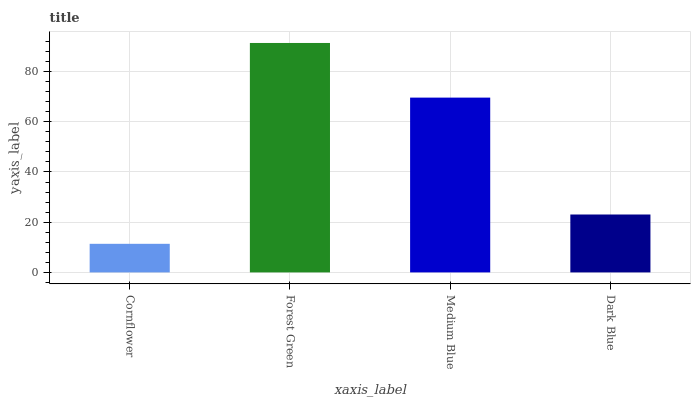Is Cornflower the minimum?
Answer yes or no. Yes. Is Forest Green the maximum?
Answer yes or no. Yes. Is Medium Blue the minimum?
Answer yes or no. No. Is Medium Blue the maximum?
Answer yes or no. No. Is Forest Green greater than Medium Blue?
Answer yes or no. Yes. Is Medium Blue less than Forest Green?
Answer yes or no. Yes. Is Medium Blue greater than Forest Green?
Answer yes or no. No. Is Forest Green less than Medium Blue?
Answer yes or no. No. Is Medium Blue the high median?
Answer yes or no. Yes. Is Dark Blue the low median?
Answer yes or no. Yes. Is Forest Green the high median?
Answer yes or no. No. Is Forest Green the low median?
Answer yes or no. No. 